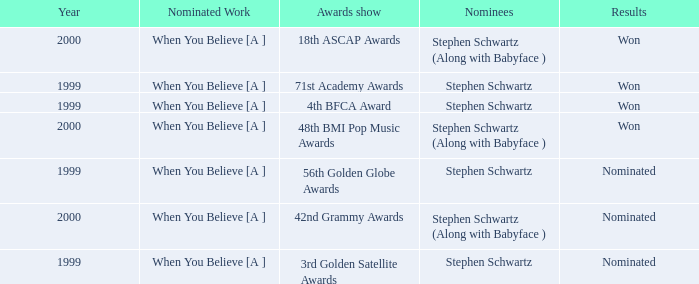Which Nominated Work won in 2000? When You Believe [A ], When You Believe [A ]. 